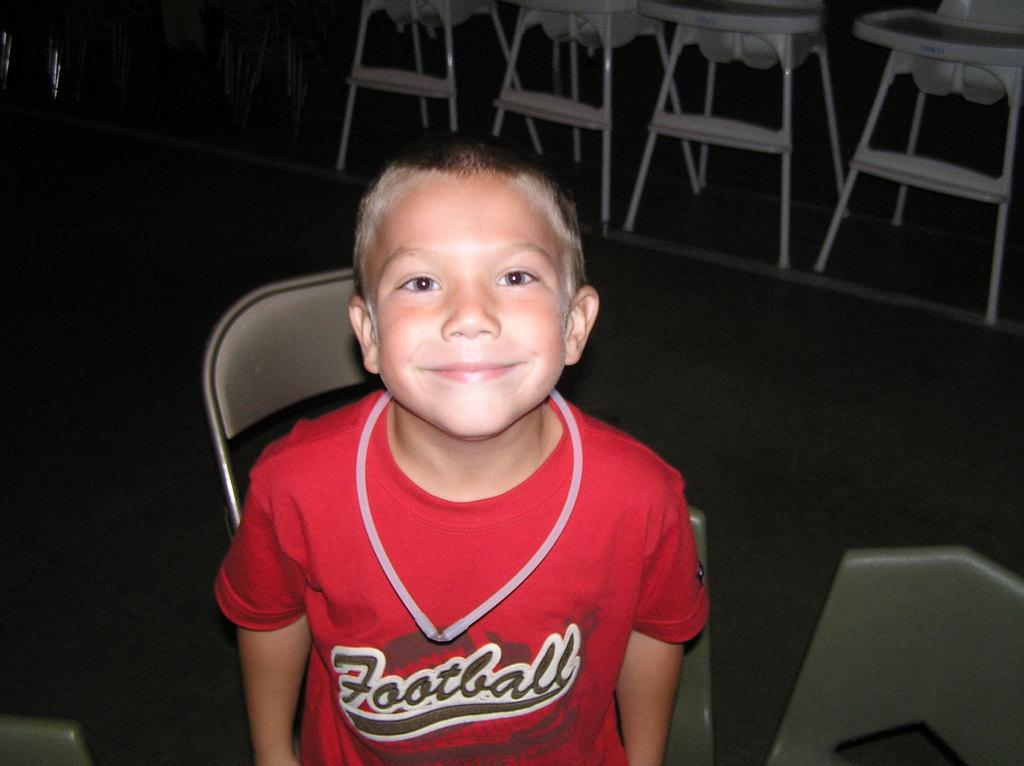<image>
Provide a brief description of the given image. A young boy wearing a red football jersey. 